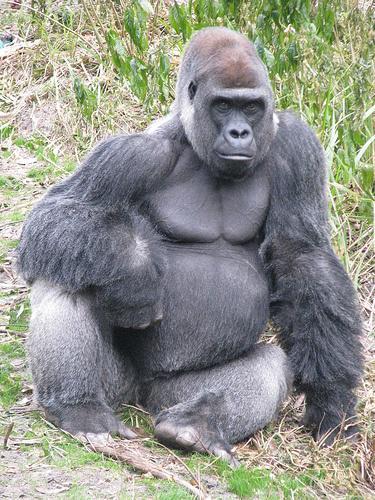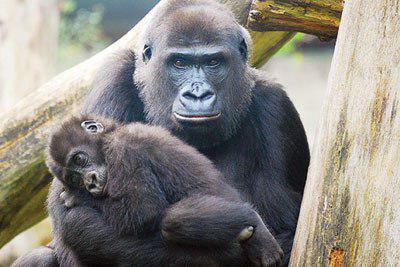The first image is the image on the left, the second image is the image on the right. Assess this claim about the two images: "An image shows a young gorilla close to an adult gorilla.". Correct or not? Answer yes or no. Yes. 